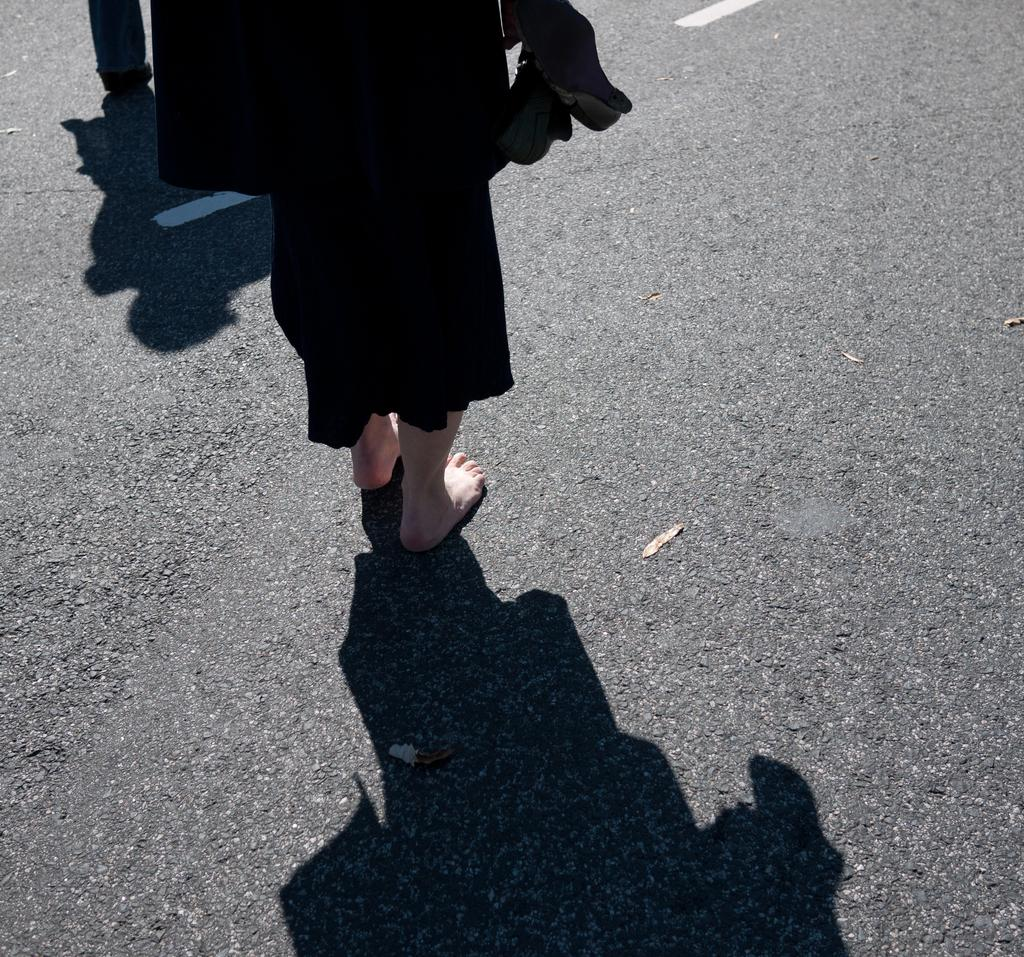Who or what is present in the image? There is a person in the image. Where is the person located? The person is standing on a road. Can you describe the road in the image? The road has white color lines on it. What is the person wearing in the image? The person is wearing a black color dress. How many ladybugs can be seen on the person's dress in the image? There are no ladybugs visible on the person's dress in the image. What type of bag is the person carrying in the image? There is no bag present in the image. 